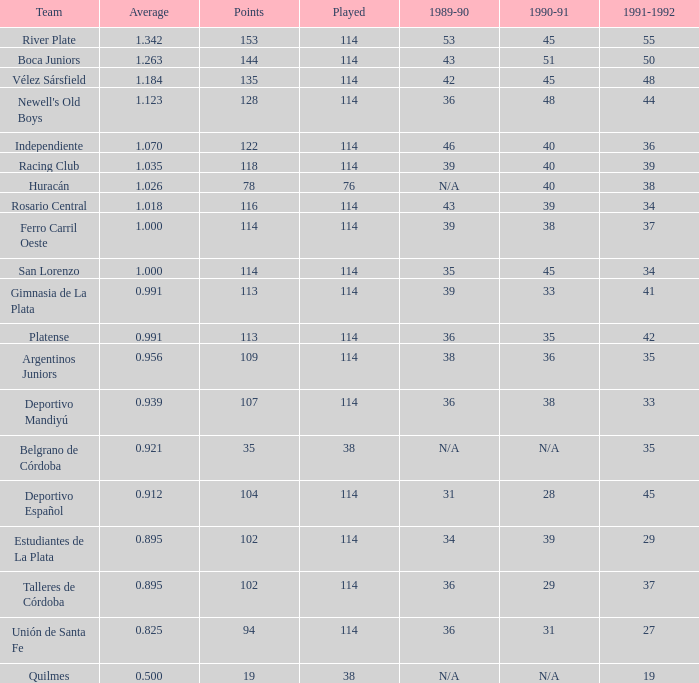9390000000000001, and a 1990-91 value of 28? 1.0. 